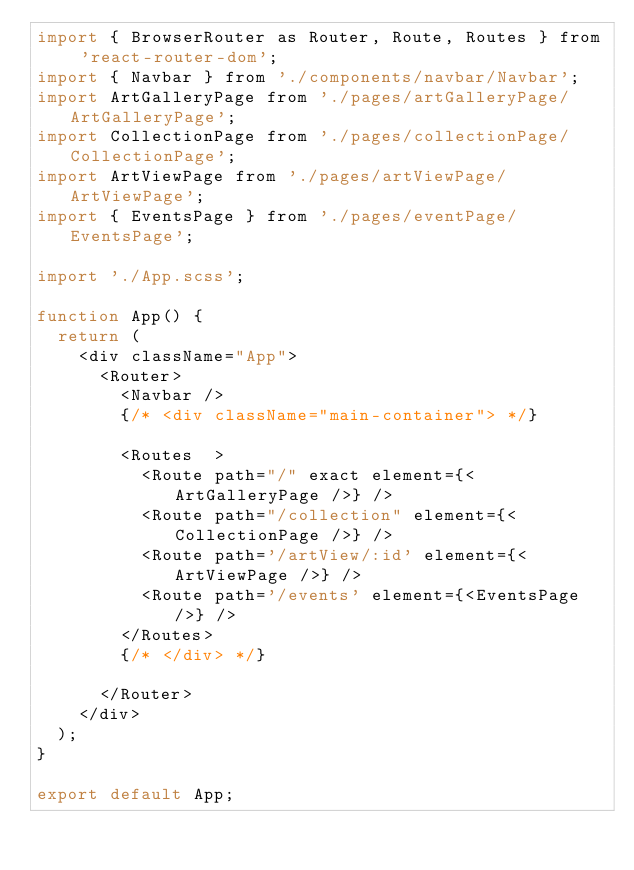Convert code to text. <code><loc_0><loc_0><loc_500><loc_500><_JavaScript_>import { BrowserRouter as Router, Route, Routes } from 'react-router-dom';
import { Navbar } from './components/navbar/Navbar';
import ArtGalleryPage from './pages/artGalleryPage/ArtGalleryPage';
import CollectionPage from './pages/collectionPage/CollectionPage';
import ArtViewPage from './pages/artViewPage/ArtViewPage';
import { EventsPage } from './pages/eventPage/EventsPage';

import './App.scss';

function App() {
  return (
    <div className="App">
      <Router>
        <Navbar />
        {/* <div className="main-container"> */}

        <Routes  >
          <Route path="/" exact element={<ArtGalleryPage />} />
          <Route path="/collection" element={<CollectionPage />} />
          <Route path='/artView/:id' element={<ArtViewPage />} />
          <Route path='/events' element={<EventsPage />} />
        </Routes>
        {/* </div> */}

      </Router>
    </div>
  );
}

export default App;
</code> 